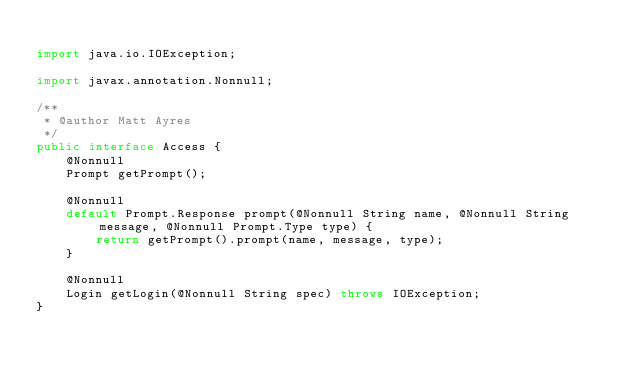<code> <loc_0><loc_0><loc_500><loc_500><_Java_>
import java.io.IOException;

import javax.annotation.Nonnull;

/**
 * @author Matt Ayres
 */
public interface Access {
	@Nonnull
	Prompt getPrompt();

	@Nonnull
	default Prompt.Response prompt(@Nonnull String name, @Nonnull String message, @Nonnull Prompt.Type type) {
		return getPrompt().prompt(name, message, type);
	}

	@Nonnull
	Login getLogin(@Nonnull String spec) throws IOException;
}
</code> 